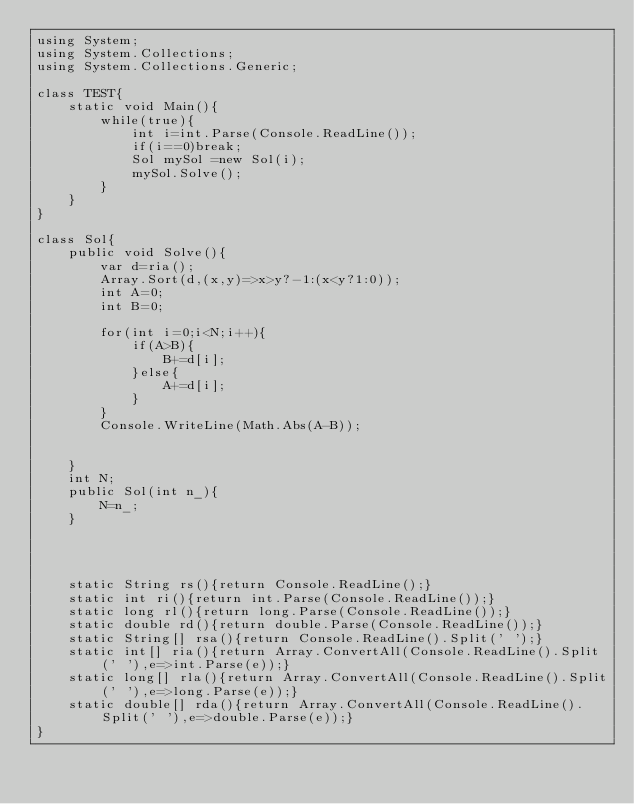<code> <loc_0><loc_0><loc_500><loc_500><_C#_>using System;
using System.Collections;
using System.Collections.Generic;
 
class TEST{
	static void Main(){
		while(true){
			int i=int.Parse(Console.ReadLine());
			if(i==0)break;
			Sol mySol =new Sol(i);
			mySol.Solve();
		}
	}
}

class Sol{
	public void Solve(){
		var d=ria();
		Array.Sort(d,(x,y)=>x>y?-1:(x<y?1:0));
		int A=0;
		int B=0;
		
		for(int i=0;i<N;i++){
			if(A>B){
				B+=d[i];
			}else{
				A+=d[i];
			}
		}
		Console.WriteLine(Math.Abs(A-B));
		
		
	}
	int N;
	public Sol(int n_){
		N=n_;
	}




	static String rs(){return Console.ReadLine();}
	static int ri(){return int.Parse(Console.ReadLine());}
	static long rl(){return long.Parse(Console.ReadLine());}
	static double rd(){return double.Parse(Console.ReadLine());}
	static String[] rsa(){return Console.ReadLine().Split(' ');}
	static int[] ria(){return Array.ConvertAll(Console.ReadLine().Split(' '),e=>int.Parse(e));}
	static long[] rla(){return Array.ConvertAll(Console.ReadLine().Split(' '),e=>long.Parse(e));}
	static double[] rda(){return Array.ConvertAll(Console.ReadLine().Split(' '),e=>double.Parse(e));}
}</code> 